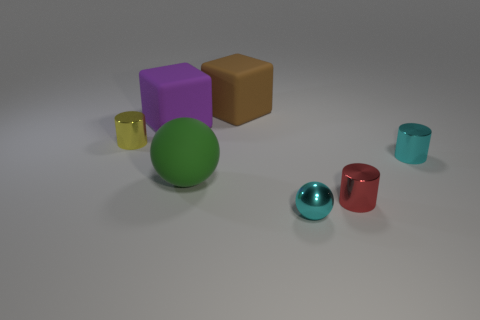What is the shape of the big brown thing that is the same material as the big green thing?
Offer a terse response. Cube. The cylinder that is to the left of the matte object that is in front of the big purple rubber thing is what color?
Keep it short and to the point. Yellow. Is the small red metallic object the same shape as the tiny yellow object?
Your answer should be compact. Yes. What material is the other object that is the same shape as the purple thing?
Ensure brevity in your answer.  Rubber. Are there any tiny balls in front of the shiny cylinder that is in front of the object to the right of the small red cylinder?
Keep it short and to the point. Yes. There is a big brown object; does it have the same shape as the tiny thing that is on the left side of the purple cube?
Make the answer very short. No. Is there any other thing that is the same color as the tiny sphere?
Offer a very short reply. Yes. Does the ball right of the large brown matte cube have the same color as the cylinder to the right of the small red thing?
Provide a short and direct response. Yes. Is there a yellow cylinder?
Offer a very short reply. Yes. Is there a red cylinder that has the same material as the red object?
Ensure brevity in your answer.  No. 